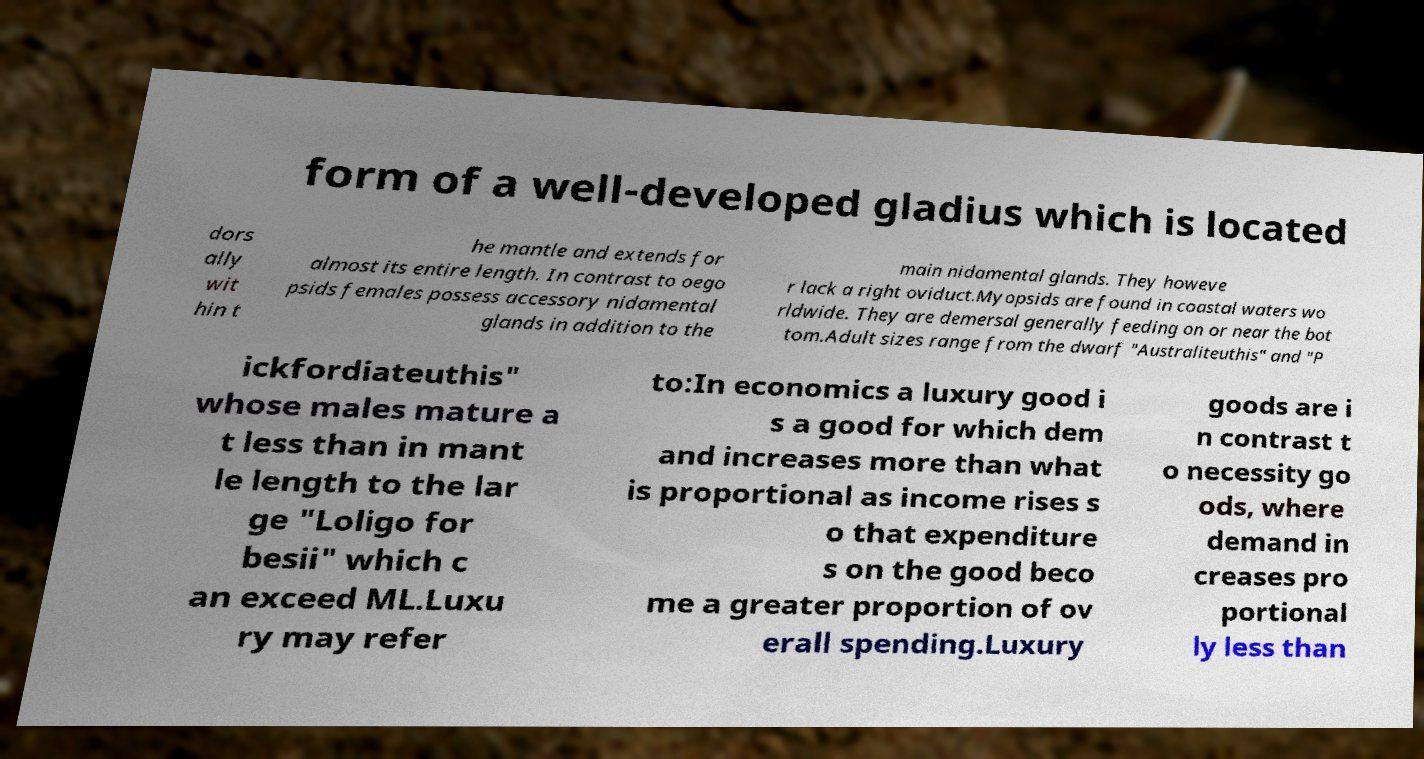Please identify and transcribe the text found in this image. form of a well-developed gladius which is located dors ally wit hin t he mantle and extends for almost its entire length. In contrast to oego psids females possess accessory nidamental glands in addition to the main nidamental glands. They howeve r lack a right oviduct.Myopsids are found in coastal waters wo rldwide. They are demersal generally feeding on or near the bot tom.Adult sizes range from the dwarf "Australiteuthis" and "P ickfordiateuthis" whose males mature a t less than in mant le length to the lar ge "Loligo for besii" which c an exceed ML.Luxu ry may refer to:In economics a luxury good i s a good for which dem and increases more than what is proportional as income rises s o that expenditure s on the good beco me a greater proportion of ov erall spending.Luxury goods are i n contrast t o necessity go ods, where demand in creases pro portional ly less than 